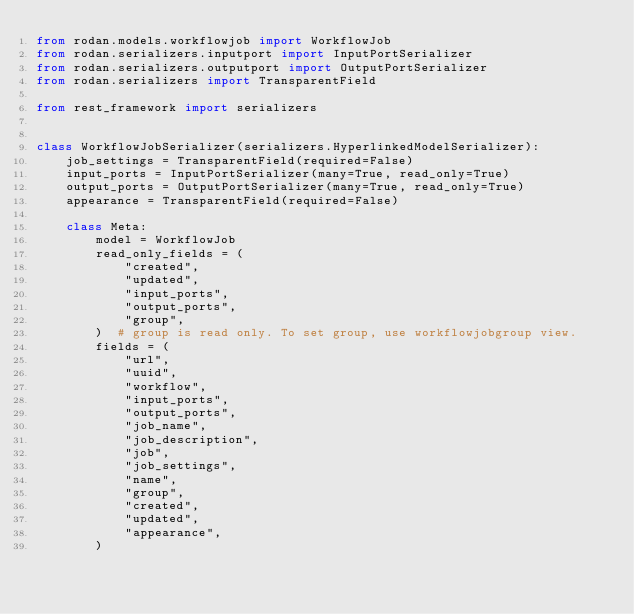Convert code to text. <code><loc_0><loc_0><loc_500><loc_500><_Python_>from rodan.models.workflowjob import WorkflowJob
from rodan.serializers.inputport import InputPortSerializer
from rodan.serializers.outputport import OutputPortSerializer
from rodan.serializers import TransparentField

from rest_framework import serializers


class WorkflowJobSerializer(serializers.HyperlinkedModelSerializer):
    job_settings = TransparentField(required=False)
    input_ports = InputPortSerializer(many=True, read_only=True)
    output_ports = OutputPortSerializer(many=True, read_only=True)
    appearance = TransparentField(required=False)

    class Meta:
        model = WorkflowJob
        read_only_fields = (
            "created",
            "updated",
            "input_ports",
            "output_ports",
            "group",
        )  # group is read only. To set group, use workflowjobgroup view.
        fields = (
            "url",
            "uuid",
            "workflow",
            "input_ports",
            "output_ports",
            "job_name",
            "job_description",
            "job",
            "job_settings",
            "name",
            "group",
            "created",
            "updated",
            "appearance",
        )
</code> 